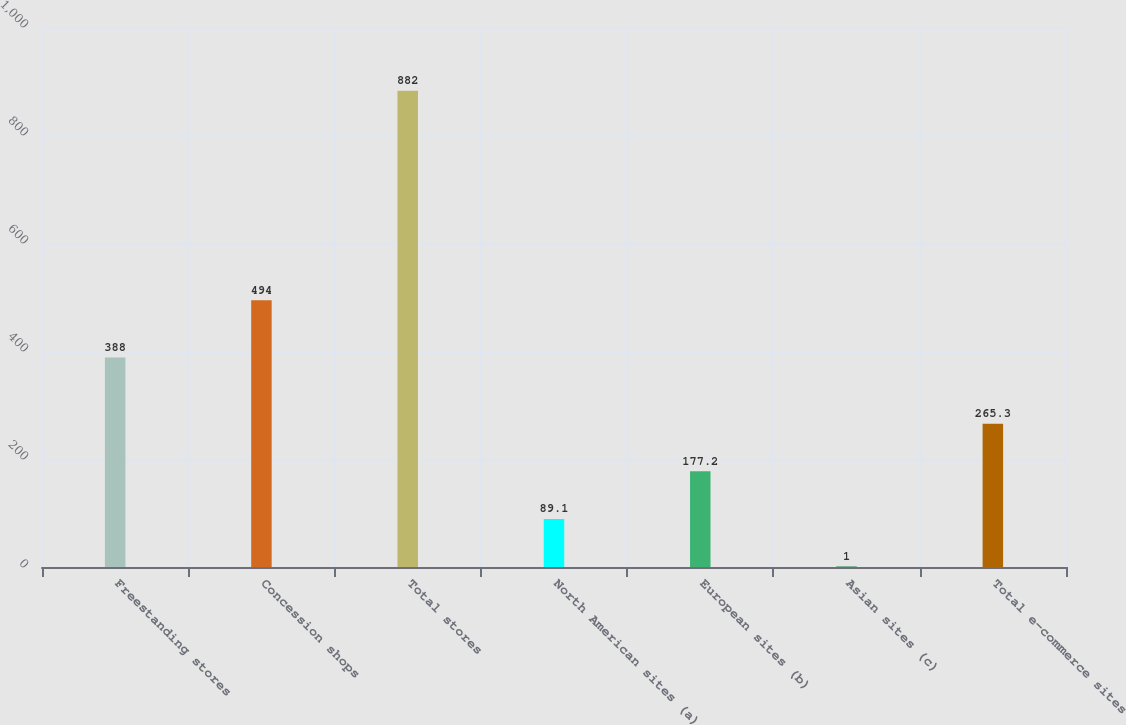Convert chart. <chart><loc_0><loc_0><loc_500><loc_500><bar_chart><fcel>Freestanding stores<fcel>Concession shops<fcel>Total stores<fcel>North American sites (a)<fcel>European sites (b)<fcel>Asian sites (c)<fcel>Total e-commerce sites<nl><fcel>388<fcel>494<fcel>882<fcel>89.1<fcel>177.2<fcel>1<fcel>265.3<nl></chart> 